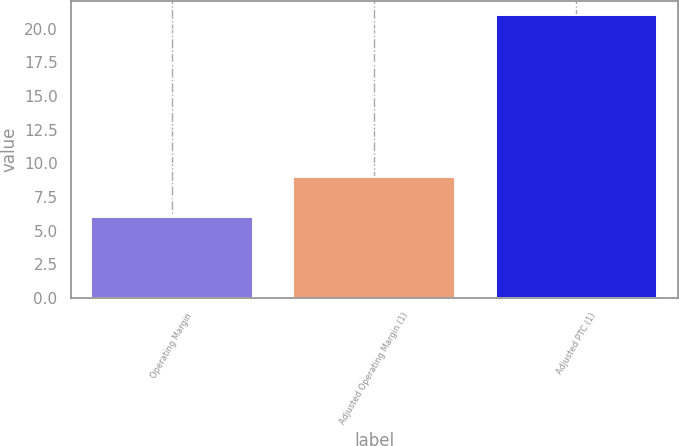Convert chart to OTSL. <chart><loc_0><loc_0><loc_500><loc_500><bar_chart><fcel>Operating Margin<fcel>Adjusted Operating Margin (1)<fcel>Adjusted PTC (1)<nl><fcel>6<fcel>9<fcel>21<nl></chart> 